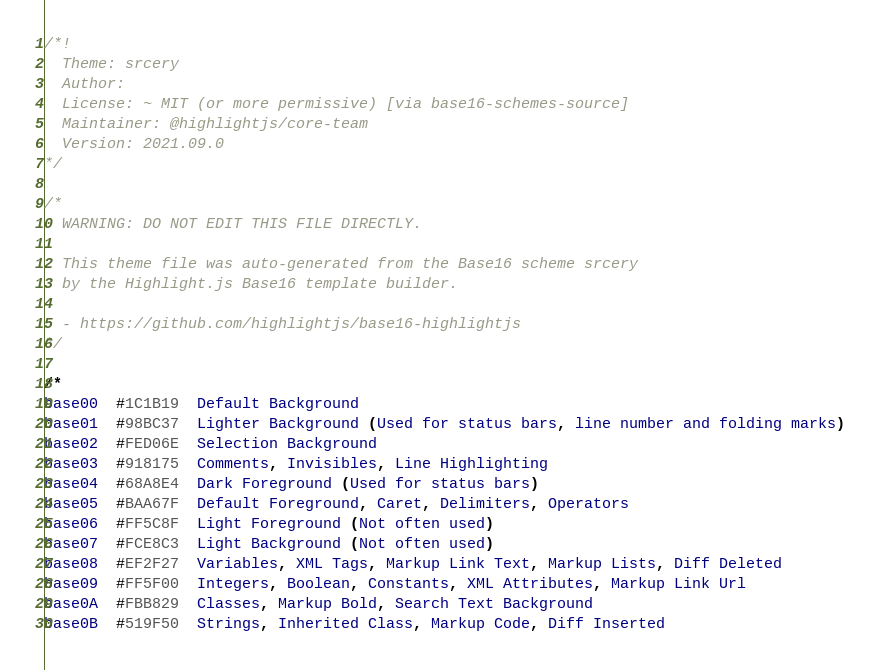<code> <loc_0><loc_0><loc_500><loc_500><_CSS_>/*!
  Theme: srcery
  Author: 
  License: ~ MIT (or more permissive) [via base16-schemes-source]
  Maintainer: @highlightjs/core-team
  Version: 2021.09.0
*/

/*
  WARNING: DO NOT EDIT THIS FILE DIRECTLY.

  This theme file was auto-generated from the Base16 scheme srcery
  by the Highlight.js Base16 template builder.

  - https://github.com/highlightjs/base16-highlightjs
*/

/*
base00  #1C1B19  Default Background
base01  #98BC37  Lighter Background (Used for status bars, line number and folding marks)
base02  #FED06E  Selection Background
base03  #918175  Comments, Invisibles, Line Highlighting
base04  #68A8E4  Dark Foreground (Used for status bars)
base05  #BAA67F  Default Foreground, Caret, Delimiters, Operators
base06  #FF5C8F  Light Foreground (Not often used)
base07  #FCE8C3  Light Background (Not often used)
base08  #EF2F27  Variables, XML Tags, Markup Link Text, Markup Lists, Diff Deleted
base09  #FF5F00  Integers, Boolean, Constants, XML Attributes, Markup Link Url
base0A  #FBB829  Classes, Markup Bold, Search Text Background
base0B  #519F50  Strings, Inherited Class, Markup Code, Diff Inserted</code> 